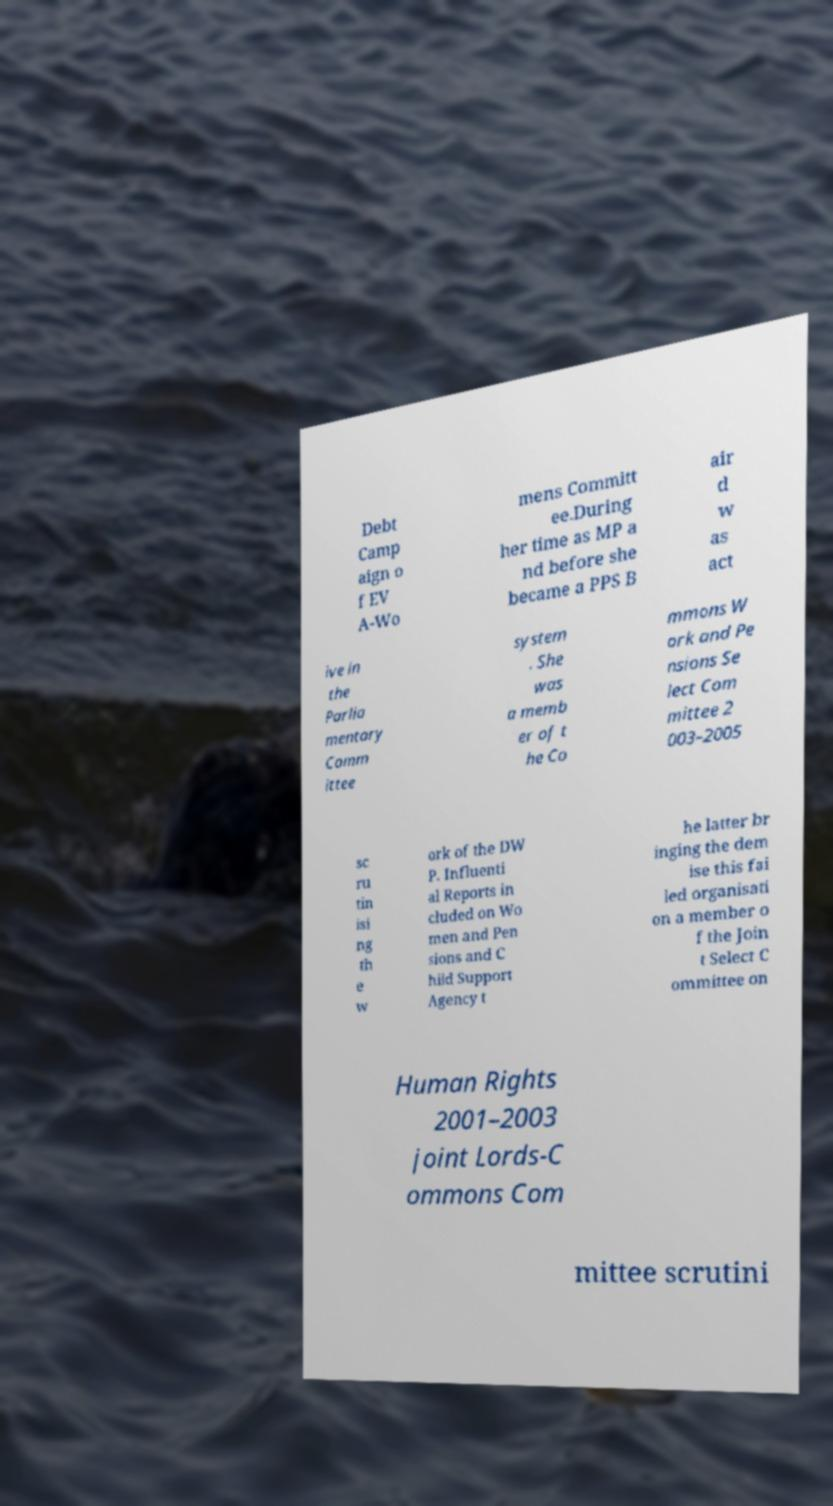Please identify and transcribe the text found in this image. Debt Camp aign o f EV A-Wo mens Committ ee.During her time as MP a nd before she became a PPS B air d w as act ive in the Parlia mentary Comm ittee system . She was a memb er of t he Co mmons W ork and Pe nsions Se lect Com mittee 2 003–2005 sc ru tin isi ng th e w ork of the DW P. Influenti al Reports in cluded on Wo men and Pen sions and C hild Support Agency t he latter br inging the dem ise this fai led organisati on a member o f the Join t Select C ommittee on Human Rights 2001–2003 joint Lords-C ommons Com mittee scrutini 